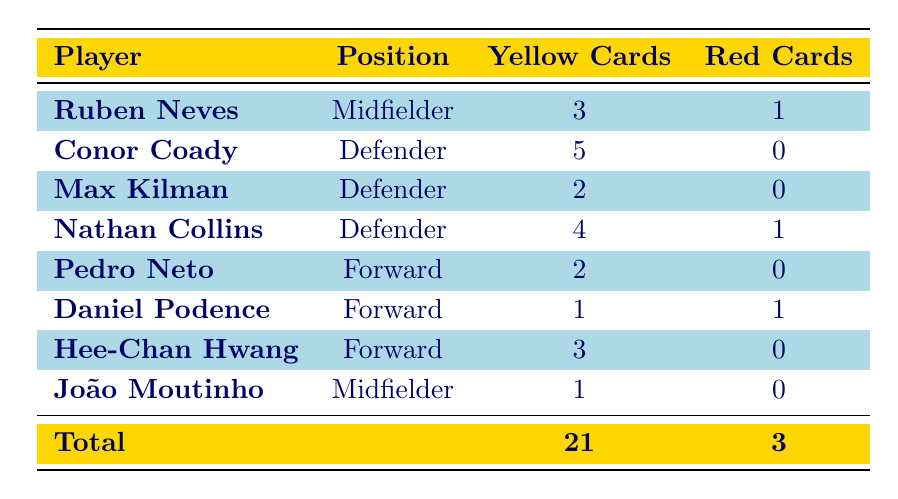What is the total number of yellow cards received by the players? The total yellow cards are explicitly stated in the table as 21.
Answer: 21 Which player has received the most yellow cards? By reviewing the table, Conor Coady has received the highest number of yellow cards, with a total of 5.
Answer: Conor Coady How many players received a red card this season? The total red cards listed in the table are 3, indicating that three different players received red cards.
Answer: 3 Is Nathan Collins a midfielder? According to the table, Nathan Collins is listed as a defender, not a midfielder.
Answer: No Which position has the highest number of cumulative yellow cards? To find this, I combine the yellow card counts by position: Midfielders (3 + 1 = 4), Defenders (5 + 2 + 4 = 11), and Forwards (2 + 1 + 3 = 6). The highest is Defenders with 11 yellow cards.
Answer: Defenders What is the average number of yellow cards per player? There are 8 players and the total yellow cards are 21. The average is calculated as 21 divided by 8, which equals 2.625.
Answer: 2.625 How many players have not received any red cards? From the table, I count the players with 0 red cards, these are: Conor Coady, Max Kilman, Pedro Neto, Hee-Chan Hwang, and João Moutinho, totaling 5 players.
Answer: 5 Is one of the forwards listed more disciplined than others in terms of cards? Analyzing the forwards: Pedro Neto (2 yellow, 0 red), Daniel Podence (1 yellow, 1 red), and Hee-Chan Hwang (3 yellow, 0 red), Hee-Chan Hwang has the most yellow cards, but none were red, indicating he is the most disciplined overall due to avoiding red cards.
Answer: Yes Which player received both yellow and red cards this season? The table lists Daniel Podence and Ruben Neves as players who received both yellow and red cards.
Answer: Daniel Podence, Ruben Neves 